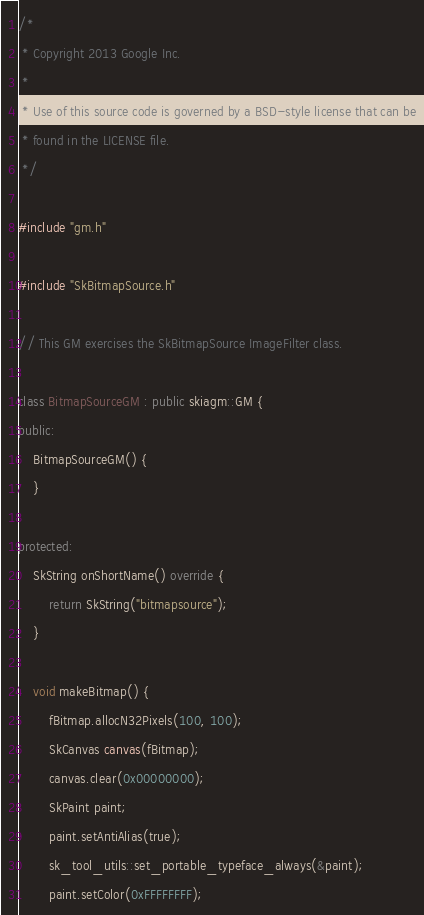<code> <loc_0><loc_0><loc_500><loc_500><_C++_>/*
 * Copyright 2013 Google Inc.
 *
 * Use of this source code is governed by a BSD-style license that can be
 * found in the LICENSE file.
 */

#include "gm.h"

#include "SkBitmapSource.h"

// This GM exercises the SkBitmapSource ImageFilter class.

class BitmapSourceGM : public skiagm::GM {
public:
    BitmapSourceGM() {
    }

protected:
    SkString onShortName() override {
        return SkString("bitmapsource");
    }

    void makeBitmap() {
        fBitmap.allocN32Pixels(100, 100);
        SkCanvas canvas(fBitmap);
        canvas.clear(0x00000000);
        SkPaint paint;
        paint.setAntiAlias(true);
        sk_tool_utils::set_portable_typeface_always(&paint);
        paint.setColor(0xFFFFFFFF);</code> 